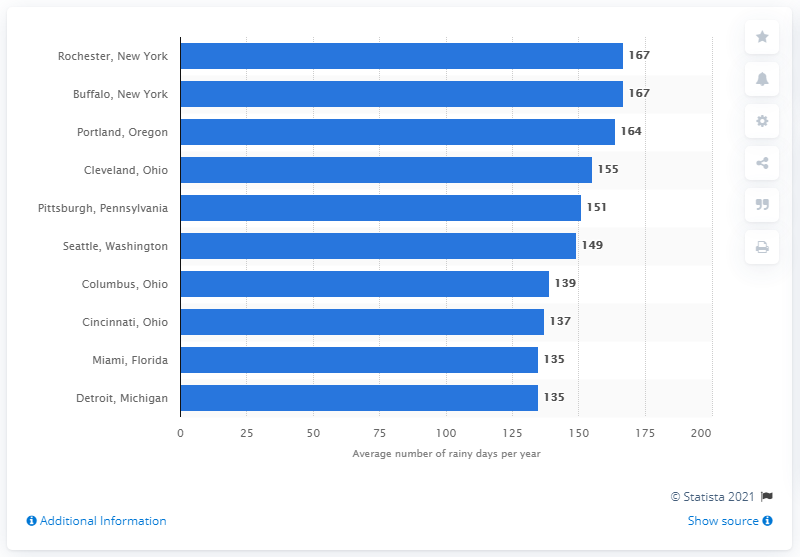Mention a couple of crucial points in this snapshot. Rochester, New York has the highest number of rainfall days out of all areas. Rochester, New York was the city that had the most rainy days per year between 1981 and 2010. There are two areas located in New York that are depicted in the chart. 